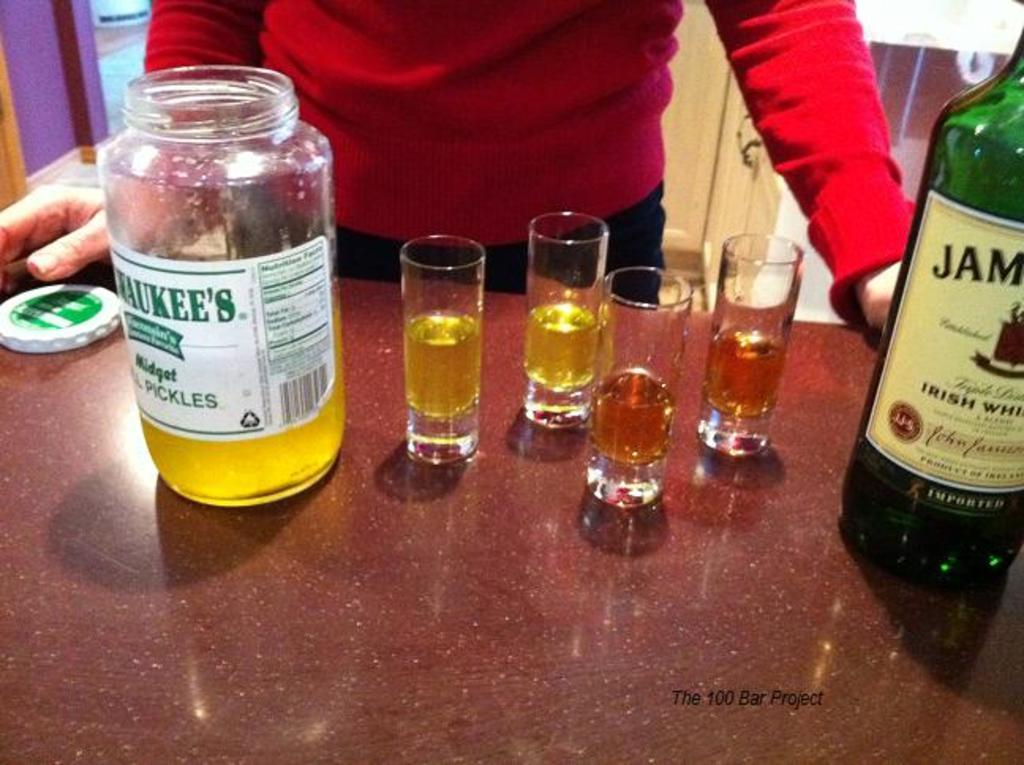What object is on the table in the image? There is a glass jar on the table. What else can be seen on the table? There are glasses with liquid and a wine bottle on the table. Is there anyone present in the image? Yes, a person is standing in front of the table. What type of band is playing in the background of the image? There is no band present in the image; it only features a table with objects and a person standing in front of it. 